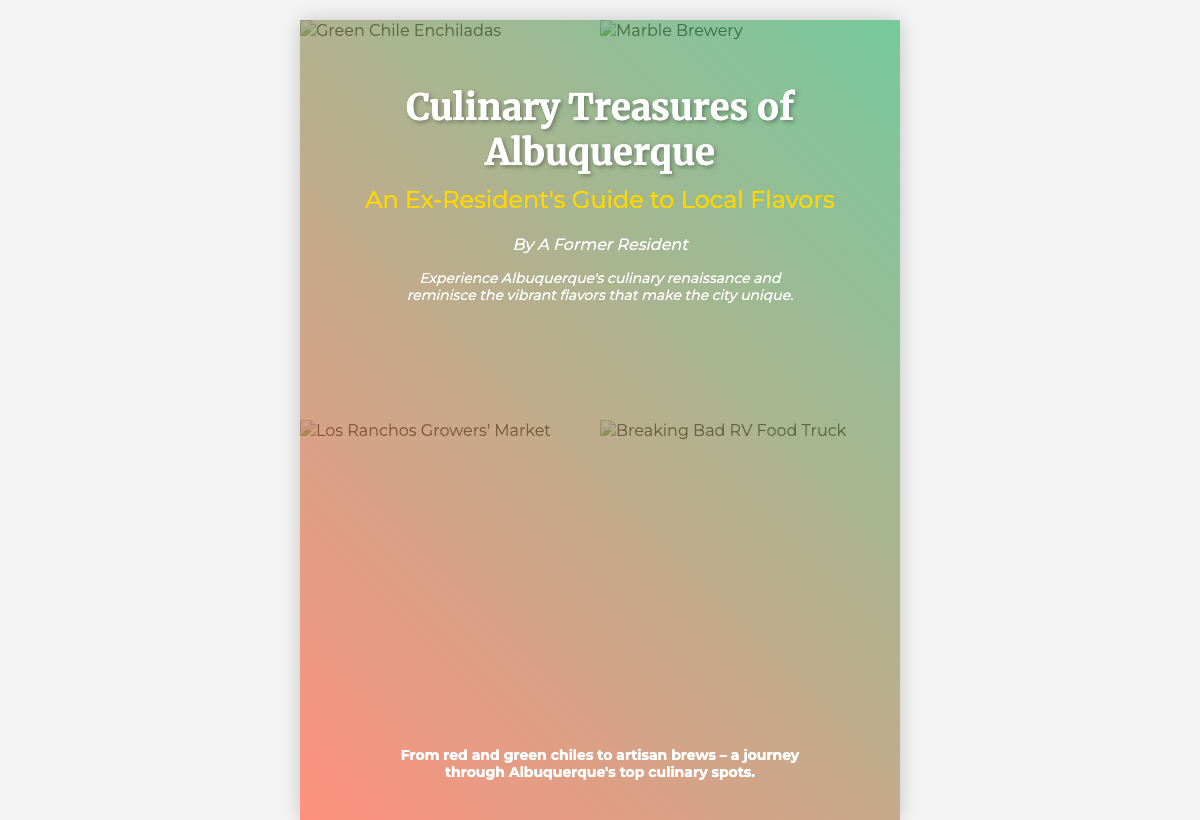what is the title of the book? The title of the book is stated at the top of the cover.
Answer: Culinary Treasures of Albuquerque who is the author of the book? The author is credited at the bottom of the overlay section.
Answer: A Former Resident how many images are present in the collage? The document specifies a grid layout containing four images.
Answer: 4 what type of food is prominently mentioned? The book cover highlights specific regional culinary items, indicating their importance.
Answer: green chiles which brewery is featured on the book cover? One of the images shows a recognizable local brewery in Albuquerque.
Answer: Marble Brewery what is the main theme of the book? The top text of the cover indicates the book focuses on the culinary aspects of Albuquerque.
Answer: culinary renaissance what is the color scheme used for the overlay? The overlay features a gradient that is described in the style section of the document layout.
Answer: colorful gradient what can readers expect to learn from the book? The bottom text provides insight into the experiences the book offers regarding local flavors.
Answer: journey through Albuquerque's top culinary spots what is the primary target audience of the book? The subtitle indicates that the guide is especially suited for those who have lived in Albuquerque before.
Answer: Ex-Residents 